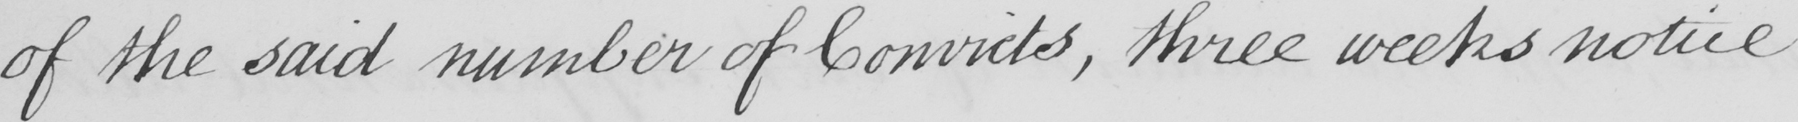Can you tell me what this handwritten text says? of the said number of Convicts , three weeks notice 